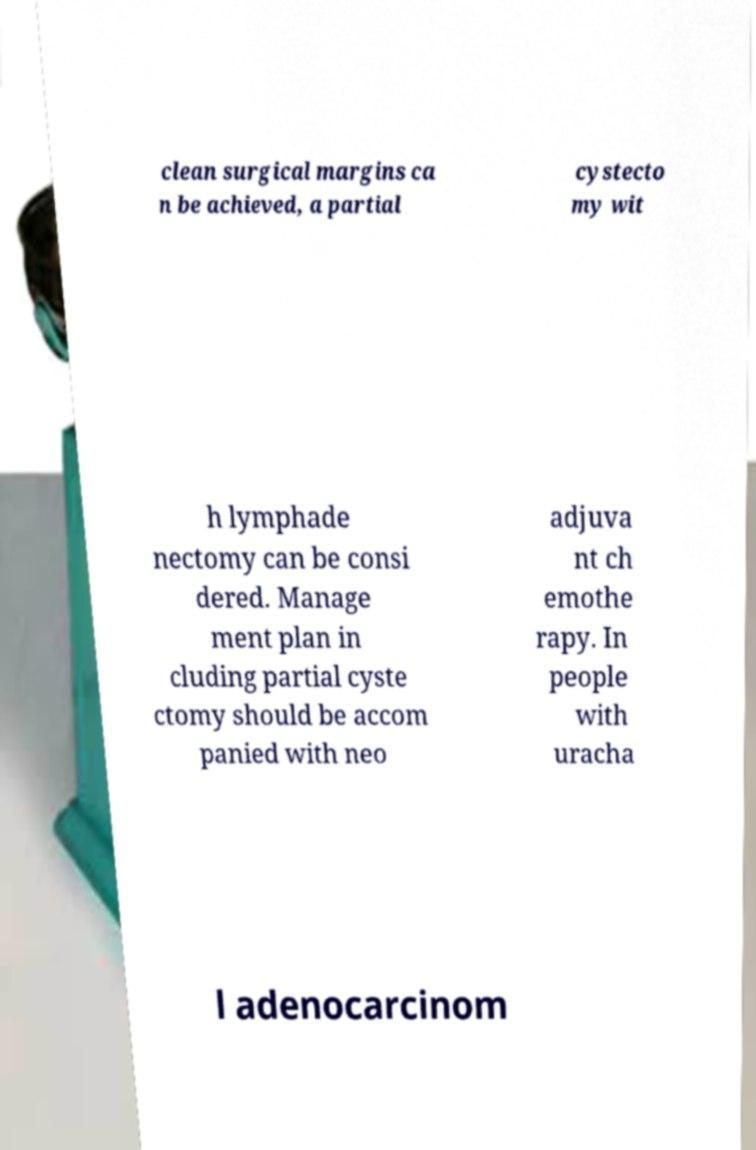Could you assist in decoding the text presented in this image and type it out clearly? clean surgical margins ca n be achieved, a partial cystecto my wit h lymphade nectomy can be consi dered. Manage ment plan in cluding partial cyste ctomy should be accom panied with neo adjuva nt ch emothe rapy. In people with uracha l adenocarcinom 